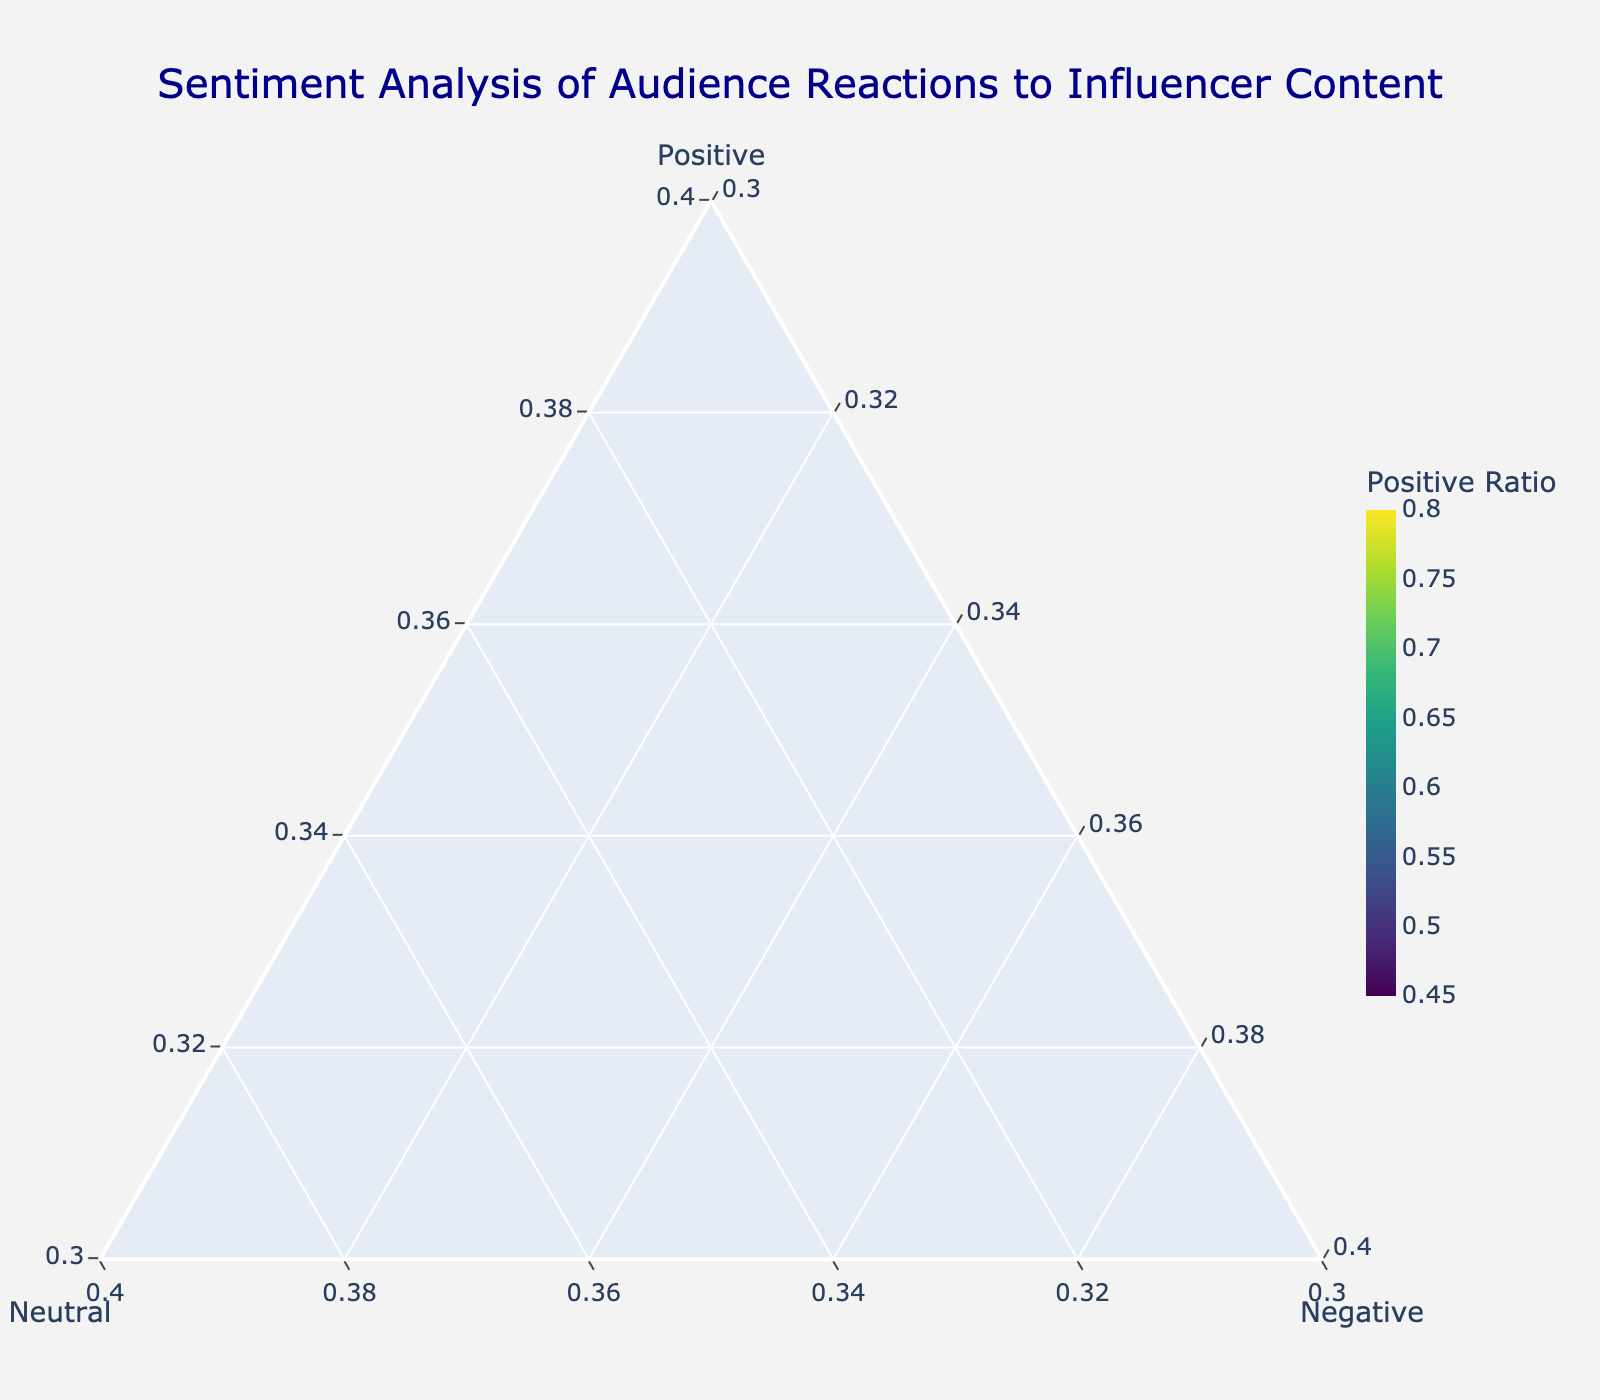What's the title of the plot? The plot title is usually located at the top and is meant to give an overview of the figure. In this case, the title reads "Sentiment Analysis of Audience Reactions to Influencer Content".
Answer: Sentiment Analysis of Audience Reactions to Influencer Content How many campaign types are represented in the plot? The number of data points in the figure represents the number of campaign types. Each point is labeled with a campaign type name. By counting these labels, we can determine there are twelve points on the plot.
Answer: 12 Which campaign type has the highest positive ratio? By looking at the color scale on the plot, the campaign type with the highest positive ratio will have the darkest color since the colorbar grades the positive ratio. "Giveaway" is the darkest point on the plot.
Answer: Giveaway Which campaign type shows the lowest neutral ratio? In a ternary plot, the ratios are represented in the axes. The campaign type which appears furthest away from the neutral axis (b-axis) will have the lowest neutral ratio. "Giveaway" and "Challenge Participation" are the furthest from the neutral axis.
Answer: Giveaway and Challenge Participation Which campaign type is closest to being balanced across all sentiment types? A balanced campaign type will be located near the center of the ternary plot where all three sentiment ratios are equal. "Brand Awareness" and "Q&A Session" appear close to the center of the plot.
Answer: Brand Awareness and Q&A Session Compare the positive sentiment ratio of 'Product Review' and 'Live Stream'. Which one is higher? To answer this, one can observe the position of the markers for 'Product Review' and 'Live Stream' along the positive axis. 'Live Stream' is positioned higher on the positive axis, meaning it has a higher positive sentiment ratio.
Answer: Live Stream Which campaign type has the most significant negative sentiment ratio? In a ternary plot, the higher negative ratio will push the point closest to the negative axis (c-axis). "Brand Awareness" and "Sponsored Post" are closest to the negative axis.
Answer: Brand Awareness and Sponsored Post What is the minimum value on each axis? The figure layout specifies each axis's minimum value as 0.3, meaning no point can be located below this value on any axis. The values for Positive, Neutral, and Negative axes are all set to start at 0.3 based on the custom settings.
Answer: 0.3 For "Behind the Scenes", what is its negative ratio given its position on the plot? By locating "Behind the Scenes" on the ternary plot, one can deduce its negative ratio by observing its position along the negative axis, which in this case shows a lower value compared to other types.
Answer: 0.05 Which campaign types have the exact same ratio of negative sentiment? Observing the figure, "Live Stream", "Lifestyle Content", "Challenge Participation", "Unboxing", and "Tutorial" are all plotted at the same vertical position against the negative axis, indicating they share the same negative ratio.
Answer: Live Stream, Lifestyle Content, Challenge Participation, Unboxing, and Tutorial 